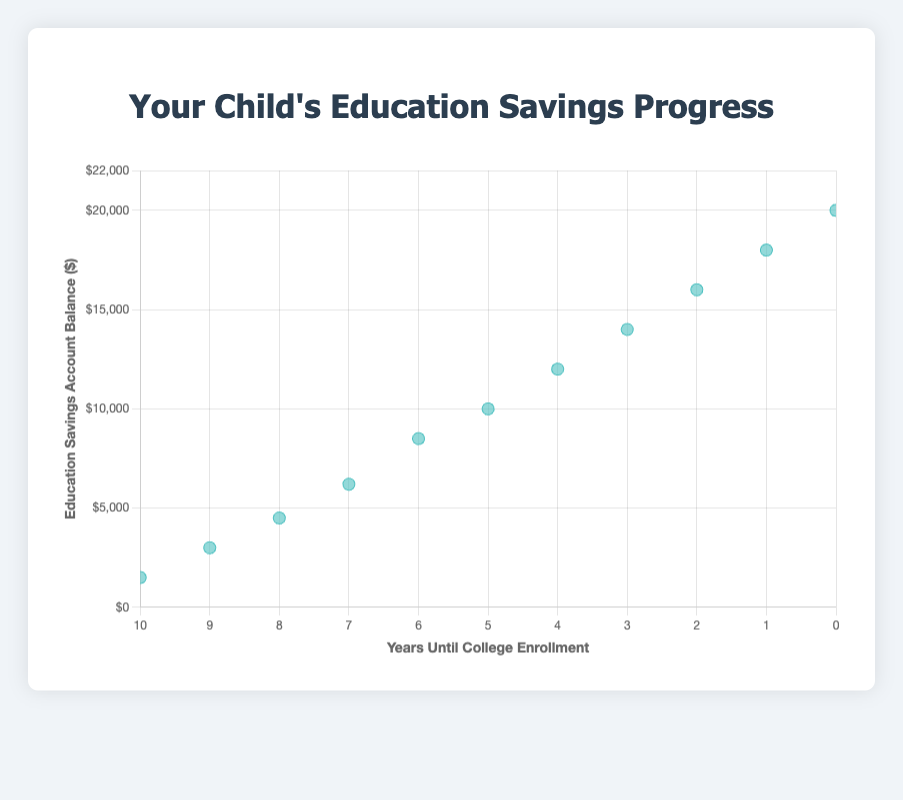What's the title of the chart? The title is typically placed at the top of the chart. In this figure, it is "Your Child's Education Savings Progress."
Answer: Your Child's Education Savings Progress How many data points are in the scatter plot? Count the number of individual dots in the plot. There are 11 data points listed in the data array.
Answer: 11 What is the label of the horizontal axis? The horizontal axis usually has a descriptive label. Here, it is labeled "Years Until College Enrollment."
Answer: Years Until College Enrollment What is the label of the vertical axis? The vertical axis typically describes what the Y-values represent. In this case, it is labeled "Education Savings Account Balance ($)."
Answer: Education Savings Account Balance ($) What is the highest Education Savings Account Balance shown? Look for the highest vertical point on the scatter plot. The data shows it at $20,000 when the Years Until College Enrollment is 0.
Answer: $20,000 What trend do you notice about Education Savings Account Balance as the Years Until College Enrollment decrease? Observe how the values change as you move from right to left along the horizontal axis. The balance increases as the years decrease.
Answer: The balance generally increases How much did the savings account balance increase from 10 years until enrollment to 5 years until enrollment? Subtract the balance at 10 years ($1,500) from the balance at 5 years ($10,000). The increase is $10,000 - $1,500 = $8,500.
Answer: $8,500 What is the average Education Savings Account Balance for the entire data set? Add all the balances: $1,500 + $3,000 + $4,500 + $6,200 + $8,500 + $10,000 + $12,000 + $14,000 + $16,000 + $18,000 + $20,000 = $113,700. Divide by 11 (number of data points): $113,700/11 ≈ $10,336.36.
Answer: $10,336.36 Which year marks a balance of $12,000? Look for the data point in the list where the balance is $12,000. It occurs when Years Until College Enrollment is 4.
Answer: 4 years What is the difference between the Education Savings Account Balances at 2 years and 1 year until enrollment? Subtract the balance at 1 year ($18,000) from the balance at 2 years ($16,000): $18,000 - $16,000 = $2,000.
Answer: $2,000 